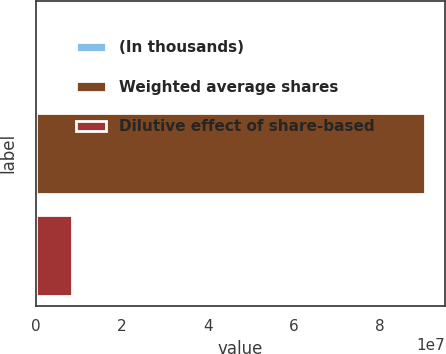Convert chart to OTSL. <chart><loc_0><loc_0><loc_500><loc_500><bar_chart><fcel>(In thousands)<fcel>Weighted average shares<fcel>Dilutive effect of share-based<nl><fcel>2017<fcel>9.05489e+07<fcel>8.24252e+06<nl></chart> 